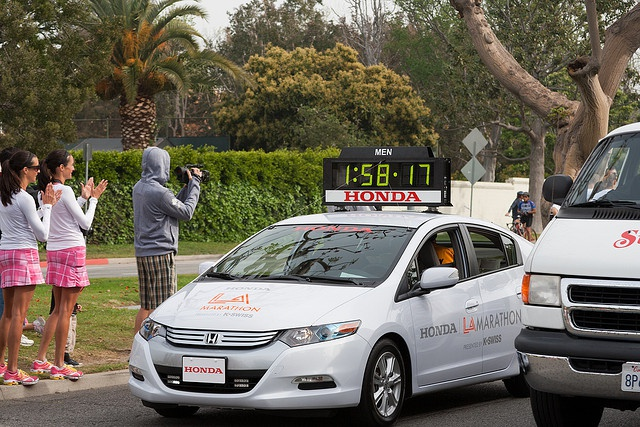Describe the objects in this image and their specific colors. I can see car in darkgreen, lightgray, darkgray, black, and gray tones, truck in darkgreen, black, lightgray, gray, and darkgray tones, people in darkgreen, gray, black, and darkgray tones, people in darkgreen, black, darkgray, lavender, and brown tones, and people in darkgreen, lightgray, brown, darkgray, and black tones in this image. 